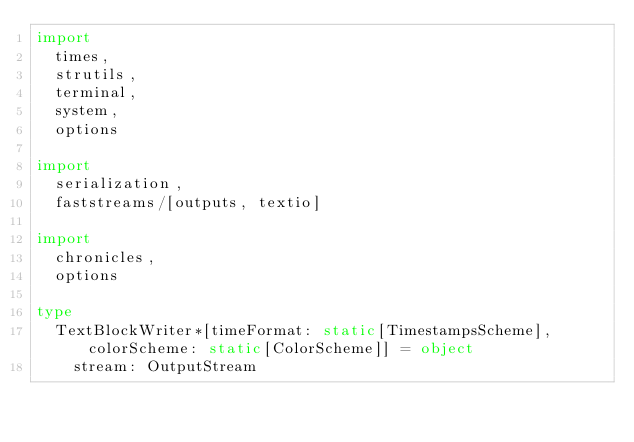Convert code to text. <code><loc_0><loc_0><loc_500><loc_500><_Nim_>import
  times,
  strutils,
  terminal,
  system,
  options

import
  serialization,
  faststreams/[outputs, textio]

import
  chronicles,
  options

type
  TextBlockWriter*[timeFormat: static[TimestampsScheme], colorScheme: static[ColorScheme]] = object
    stream: OutputStream</code> 